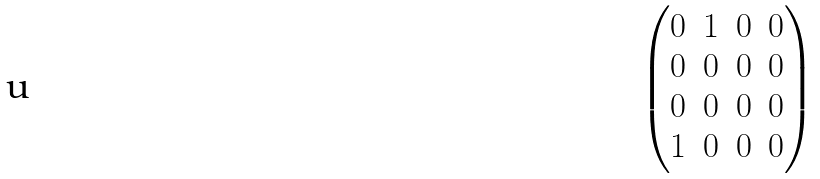Convert formula to latex. <formula><loc_0><loc_0><loc_500><loc_500>\begin{pmatrix} 0 & 1 & 0 & 0 \\ 0 & 0 & 0 & 0 \\ 0 & 0 & 0 & 0 \\ 1 & 0 & 0 & 0 \end{pmatrix}</formula> 